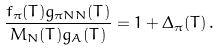<formula> <loc_0><loc_0><loc_500><loc_500>\frac { f _ { \pi } ( T ) g _ { \pi N N } ( T ) } { M _ { N } ( T ) g _ { A } ( T ) } = 1 + \Delta _ { \pi } ( T ) \, .</formula> 